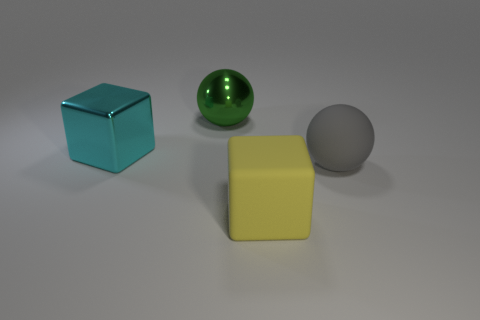Add 4 cyan metal things. How many objects exist? 8 Subtract all large gray rubber balls. Subtract all big rubber objects. How many objects are left? 1 Add 1 big matte cubes. How many big matte cubes are left? 2 Add 4 metallic objects. How many metallic objects exist? 6 Subtract 1 yellow cubes. How many objects are left? 3 